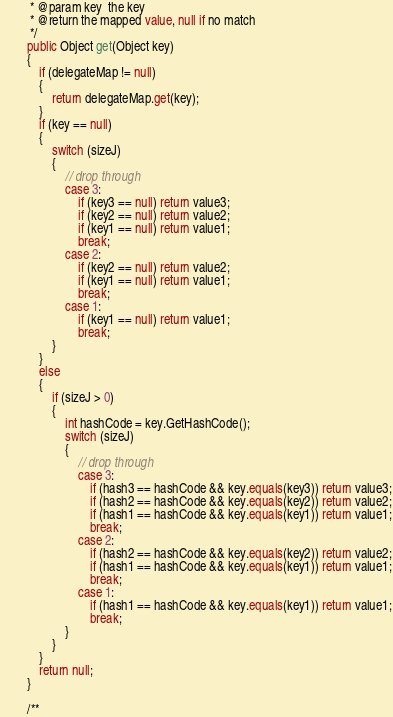<code> <loc_0><loc_0><loc_500><loc_500><_C#_>         * @param key  the key
         * @return the mapped value, null if no match
         */
        public Object get(Object key)
        {
            if (delegateMap != null)
            {
                return delegateMap.get(key);
            }
            if (key == null)
            {
                switch (sizeJ)
                {
                    // drop through
                    case 3:
                        if (key3 == null) return value3;
                        if (key2 == null) return value2;
                        if (key1 == null) return value1;
                        break;
                    case 2:
                        if (key2 == null) return value2;
                        if (key1 == null) return value1;
                        break;
                    case 1:
                        if (key1 == null) return value1;
                        break;
                }
            }
            else
            {
                if (sizeJ > 0)
                {
                    int hashCode = key.GetHashCode();
                    switch (sizeJ)
                    {
                        // drop through
                        case 3:
                            if (hash3 == hashCode && key.equals(key3)) return value3;
                            if (hash2 == hashCode && key.equals(key2)) return value2;
                            if (hash1 == hashCode && key.equals(key1)) return value1;
                            break;
                        case 2:
                            if (hash2 == hashCode && key.equals(key2)) return value2;
                            if (hash1 == hashCode && key.equals(key1)) return value1;
                            break;
                        case 1:
                            if (hash1 == hashCode && key.equals(key1)) return value1;
                            break;
                    }
                }
            }
            return null;
        }

        /**</code> 